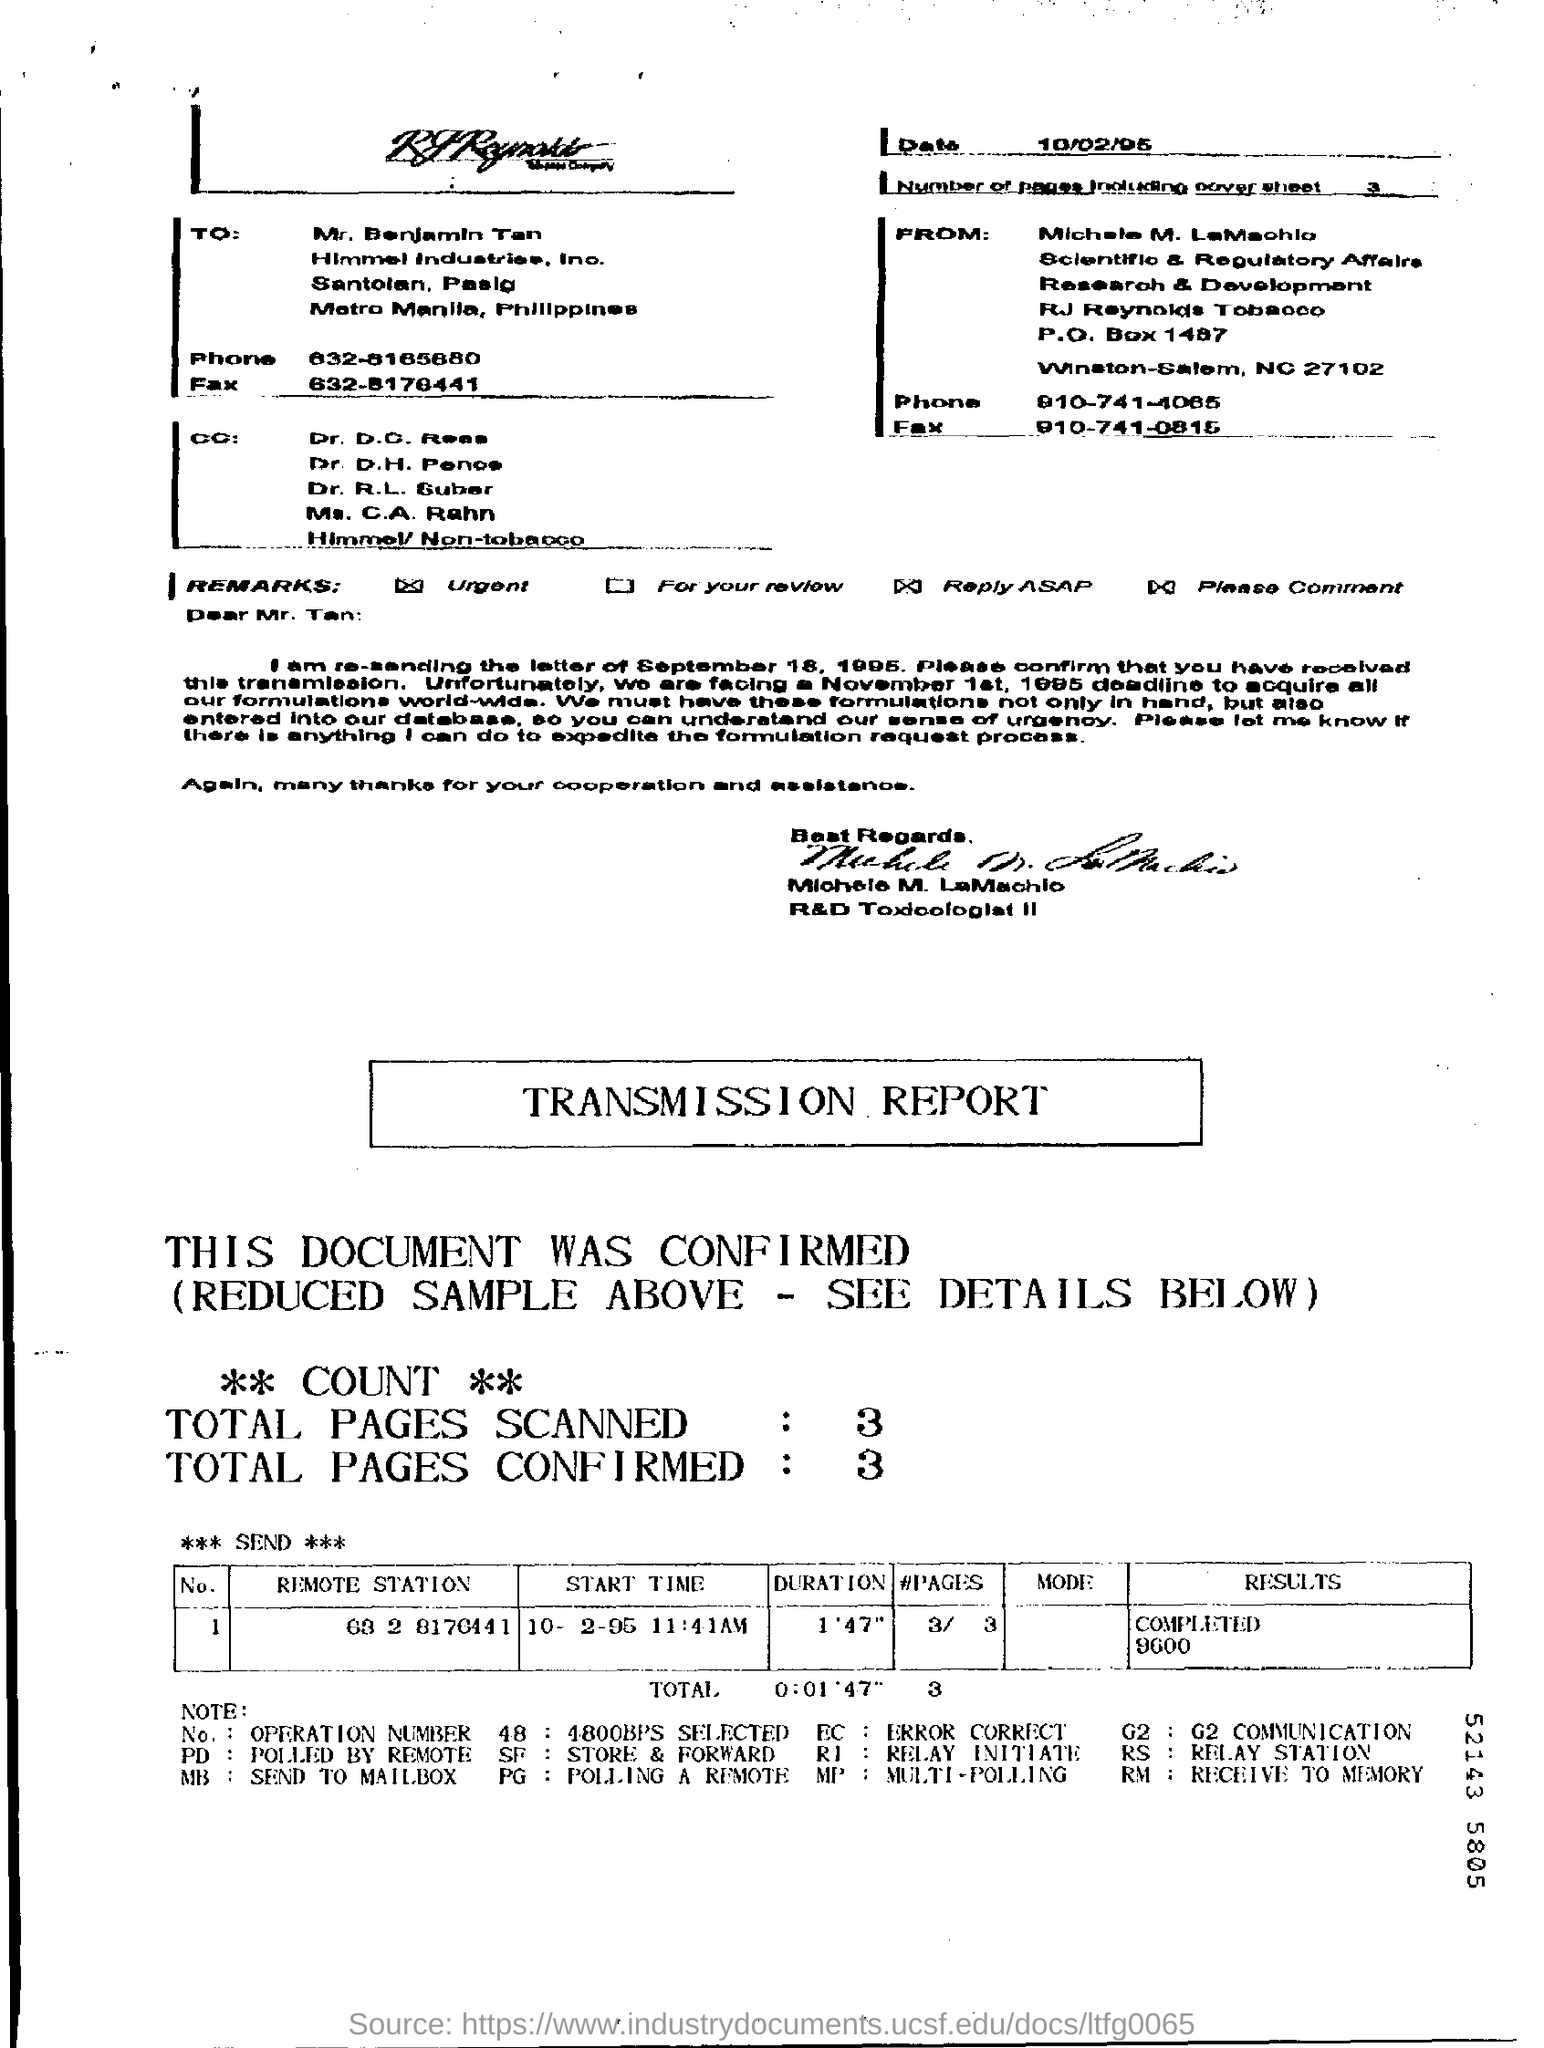Who is the receiver of the fax?
Offer a very short reply. Mr. benjamin tan. What is the number of pages in the fax including cover sheet?
Offer a terse response. 3. What is the duration mentioned in the transmission report?
Give a very brief answer. 0:01'47". 